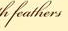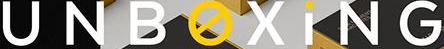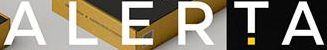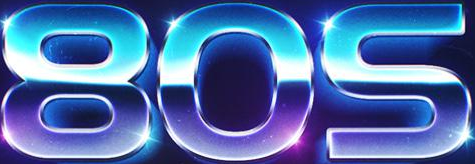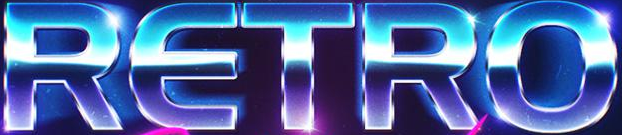Identify the words shown in these images in order, separated by a semicolon. feathers; UNBOXiNG; ALERTA; 80S; RETRO 